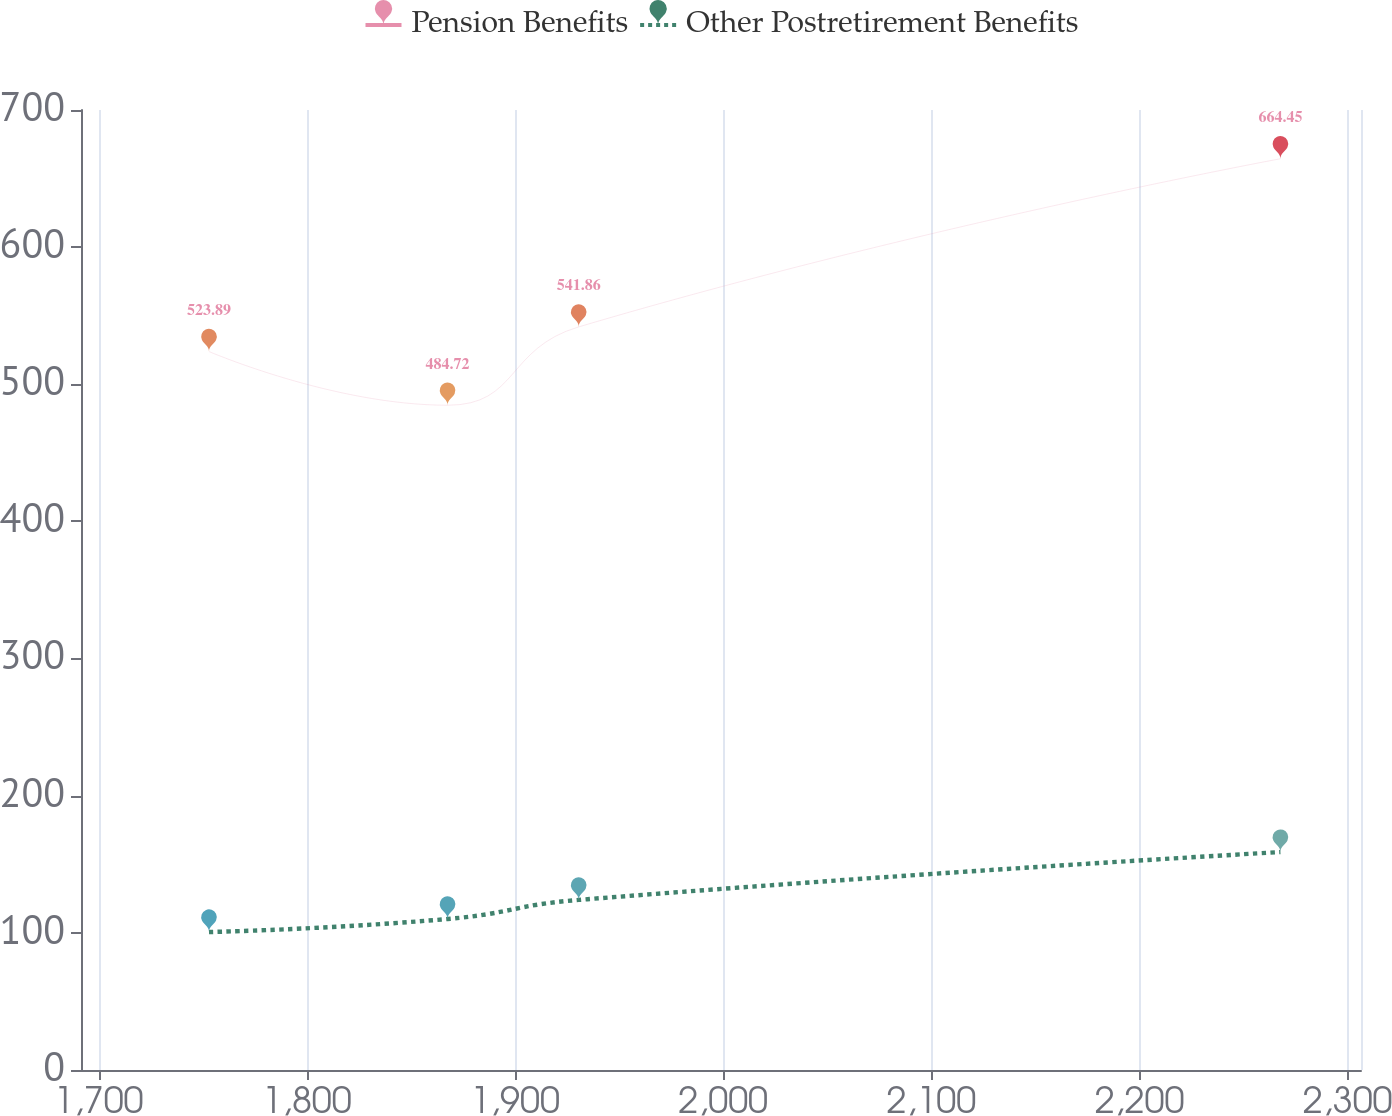Convert chart. <chart><loc_0><loc_0><loc_500><loc_500><line_chart><ecel><fcel>Pension Benefits<fcel>Other Postretirement Benefits<nl><fcel>1752.99<fcel>523.89<fcel>100.6<nl><fcel>1867.6<fcel>484.72<fcel>110.12<nl><fcel>1930.6<fcel>541.86<fcel>124.02<nl><fcel>2267.69<fcel>664.45<fcel>158.91<nl><fcel>2367.89<fcel>559.83<fcel>129.85<nl></chart> 